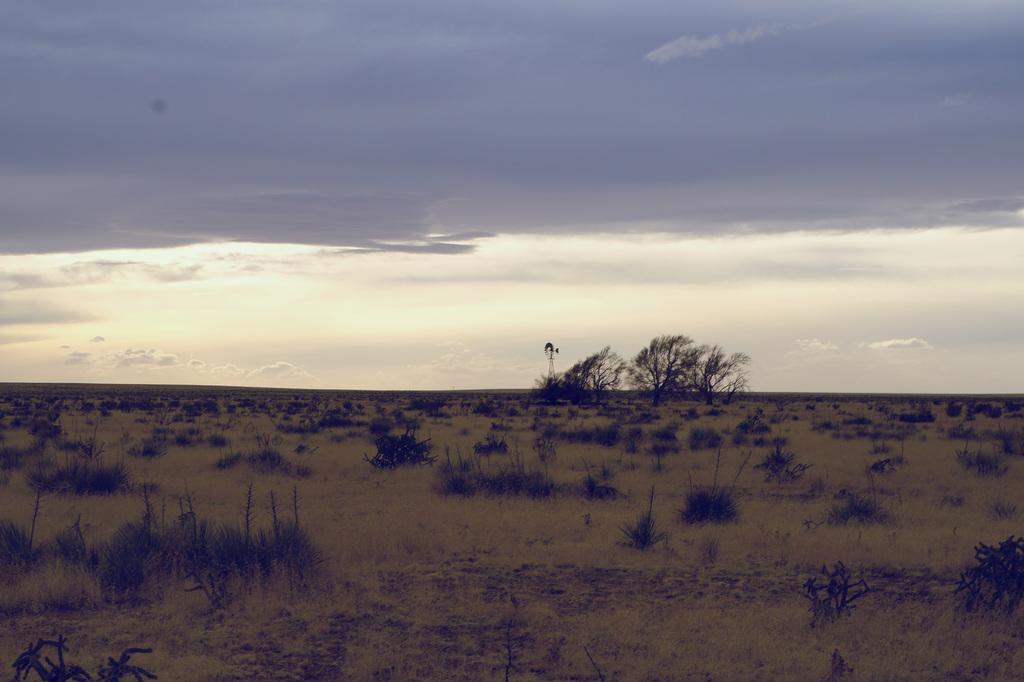What is the main feature of the image? The center of the image contains the sky. What can be seen in the sky? Clouds are present in the sky. What type of vegetation is visible in the image? Trees, plants, and grass are visible in the image. What object can be seen standing upright in the image? There is a pole in the image. What type of pot is placed on the middle of the thing in the image? There is no pot or "thing" present in the image; the main feature is the sky with clouds. 